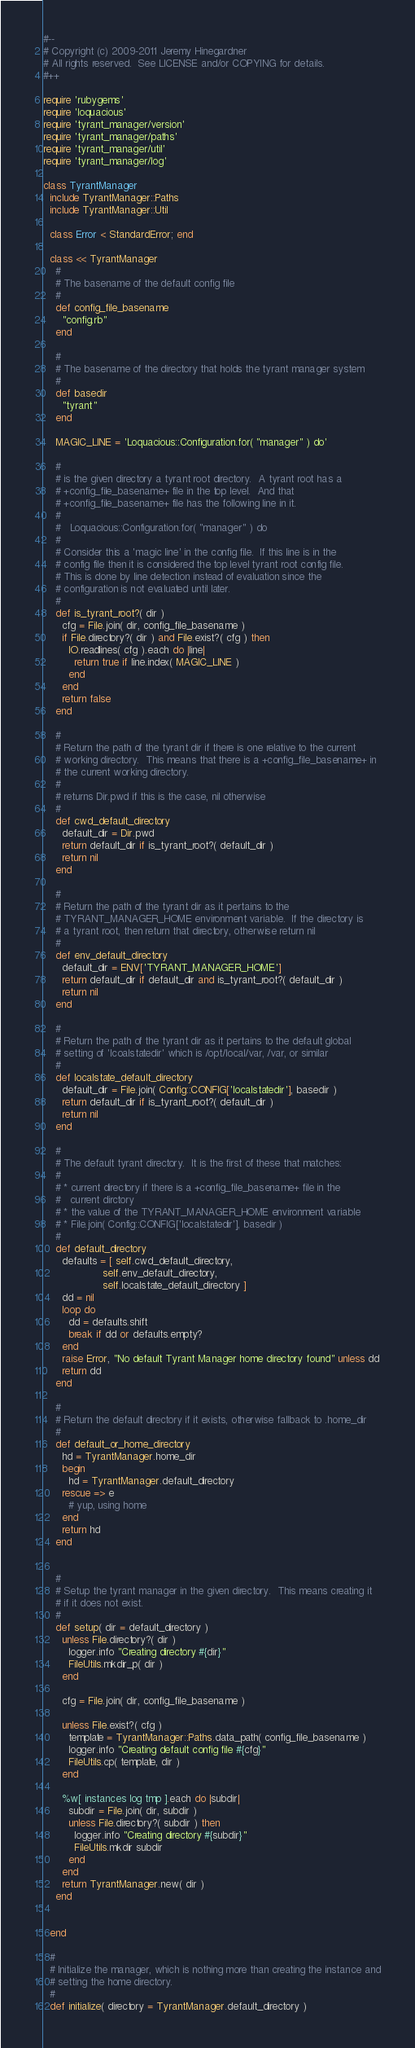<code> <loc_0><loc_0><loc_500><loc_500><_Ruby_>#--
# Copyright (c) 2009-2011 Jeremy Hinegardner
# All rights reserved.  See LICENSE and/or COPYING for details.
#++

require 'rubygems'
require 'loquacious'
require 'tyrant_manager/version'
require 'tyrant_manager/paths'
require 'tyrant_manager/util'
require 'tyrant_manager/log'

class TyrantManager
  include TyrantManager::Paths
  include TyrantManager::Util

  class Error < StandardError; end

  class << TyrantManager
    #
    # The basename of the default config file
    #
    def config_file_basename
      "config.rb"
    end

    #
    # The basename of the directory that holds the tyrant manager system
    #
    def basedir
      "tyrant"
    end

    MAGIC_LINE = 'Loquacious::Configuration.for( "manager" ) do'

    #
    # is the given directory a tyrant root directory.  A tyrant root has a
    # +config_file_basename+ file in the top level.  And that
    # +config_file_basename+ file has the following line in it.
    #
    #   Loquacious::Configuration.for( "manager" ) do
    #
    # Consider this a 'magic line' in the config file.  If this line is in the
    # config file then it is considered the top level tyrant root config file.
    # This is done by line detection instead of evaluation since the
    # configuration is not evaluated until later.
    #
    def is_tyrant_root?( dir )
      cfg = File.join( dir, config_file_basename )
      if File.directory?( dir ) and File.exist?( cfg ) then
        IO.readlines( cfg ).each do |line|
          return true if line.index( MAGIC_LINE )
        end
      end
      return false
    end

    #
    # Return the path of the tyrant dir if there is one relative to the current
    # working directory.  This means that there is a +config_file_basename+ in
    # the current working directory.
    #
    # returns Dir.pwd if this is the case, nil otherwise
    #
    def cwd_default_directory
      default_dir = Dir.pwd
      return default_dir if is_tyrant_root?( default_dir )
      return nil
    end

    # 
    # Return the path of the tyrant dir as it pertains to the
    # TYRANT_MANAGER_HOME environment variable.  If the directory is 
    # a tyrant root, then return that directory, otherwise return nil
    #
    def env_default_directory
      default_dir = ENV['TYRANT_MANAGER_HOME']
      return default_dir if default_dir and is_tyrant_root?( default_dir )
      return nil
    end

    #
    # Return the path of the tyrant dir as it pertains to the default global
    # setting of 'lcoalstatedir' which is /opt/local/var, /var, or similar
    #
    def localstate_default_directory
      default_dir = File.join( Config::CONFIG['localstatedir'], basedir )
      return default_dir if is_tyrant_root?( default_dir )
      return nil
    end

    #
    # The default tyrant directory.  It is the first of these that matches:
    #
    # * current directory if there is a +config_file_basename+ file in the
    #   current dirctory
    # * the value of the TYRANT_MANAGER_HOME environment variable
    # * File.join( Config::CONFIG['localstatedir'], basedir )
    #
    def default_directory
      defaults = [ self.cwd_default_directory,
                   self.env_default_directory,
                   self.localstate_default_directory ]
      dd = nil
      loop do
        dd = defaults.shift
        break if dd or defaults.empty?
      end
      raise Error, "No default Tyrant Manager home directory found" unless dd
      return dd
    end

    #
    # Return the default directory if it exists, otherwise fallback to .home_dir
    #
    def default_or_home_directory
      hd = TyrantManager.home_dir
      begin
        hd = TyrantManager.default_directory
      rescue => e
        # yup, using home
      end
      return hd
    end


    #
    # Setup the tyrant manager in the given directory.  This means creating it
    # if it does not exist.
    #
    def setup( dir = default_directory )
      unless File.directory?( dir )
        logger.info "Creating directory #{dir}"
        FileUtils.mkdir_p( dir )
      end

      cfg = File.join( dir, config_file_basename )

      unless File.exist?( cfg )
        template = TyrantManager::Paths.data_path( config_file_basename )
        logger.info "Creating default config file #{cfg}"
        FileUtils.cp( template, dir )
      end

      %w[ instances log tmp ].each do |subdir|
        subdir = File.join( dir, subdir )
        unless File.directory?( subdir ) then
          logger.info "Creating directory #{subdir}"
          FileUtils.mkdir subdir 
        end
      end
      return TyrantManager.new( dir )
    end


  end

  #
  # Initialize the manager, which is nothing more than creating the instance and
  # setting the home directory.
  #
  def initialize( directory = TyrantManager.default_directory )</code> 